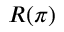<formula> <loc_0><loc_0><loc_500><loc_500>R ( \pi )</formula> 